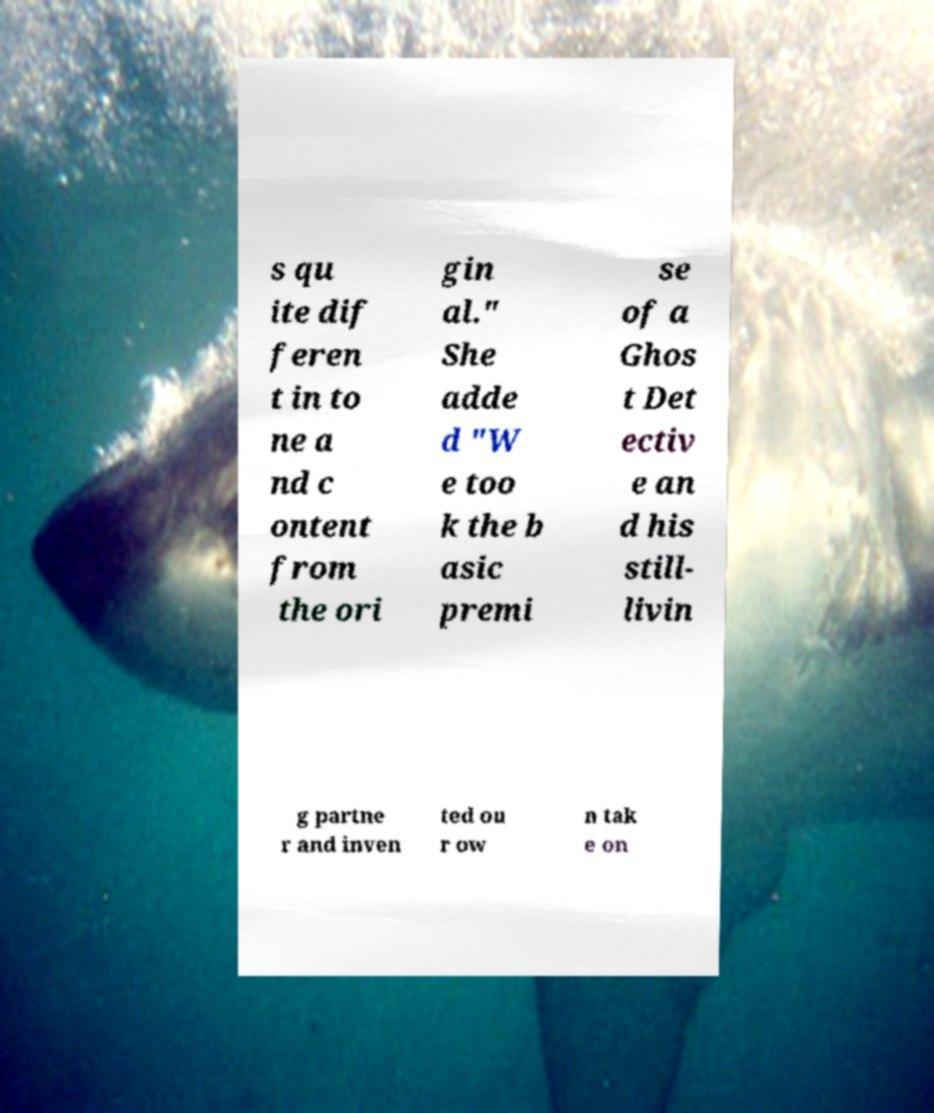For documentation purposes, I need the text within this image transcribed. Could you provide that? s qu ite dif feren t in to ne a nd c ontent from the ori gin al." She adde d "W e too k the b asic premi se of a Ghos t Det ectiv e an d his still- livin g partne r and inven ted ou r ow n tak e on 